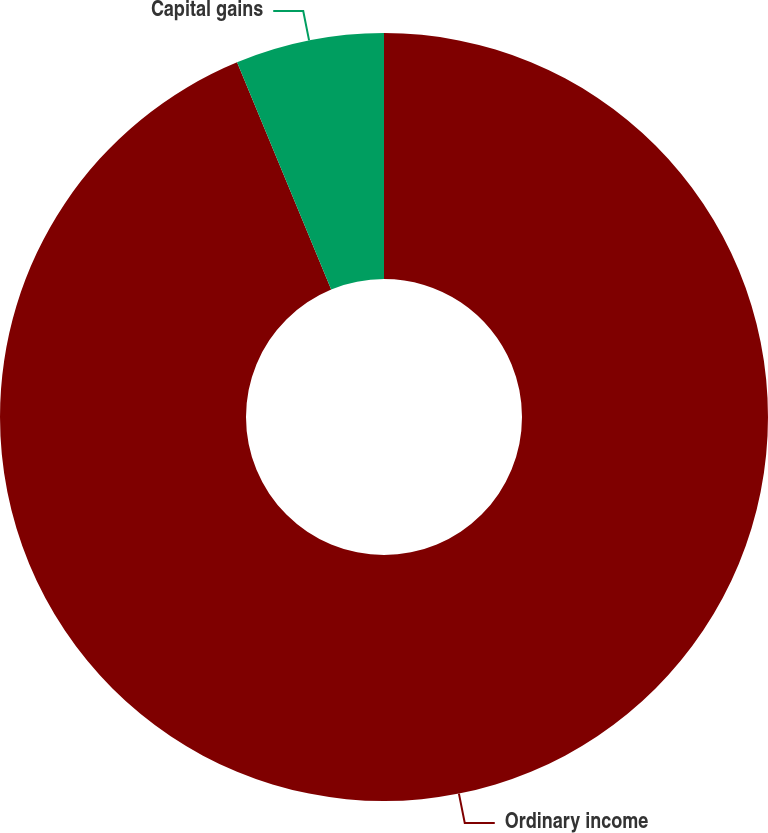Convert chart. <chart><loc_0><loc_0><loc_500><loc_500><pie_chart><fcel>Ordinary income<fcel>Capital gains<nl><fcel>93.75%<fcel>6.25%<nl></chart> 